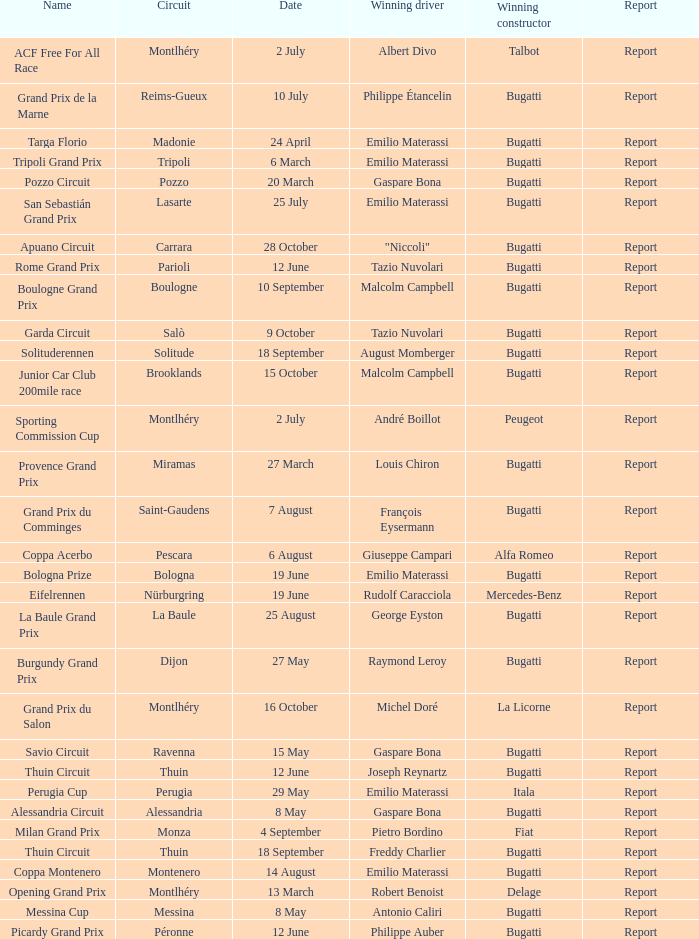Could you parse the entire table? {'header': ['Name', 'Circuit', 'Date', 'Winning driver', 'Winning constructor', 'Report'], 'rows': [['ACF Free For All Race', 'Montlhéry', '2 July', 'Albert Divo', 'Talbot', 'Report'], ['Grand Prix de la Marne', 'Reims-Gueux', '10 July', 'Philippe Étancelin', 'Bugatti', 'Report'], ['Targa Florio', 'Madonie', '24 April', 'Emilio Materassi', 'Bugatti', 'Report'], ['Tripoli Grand Prix', 'Tripoli', '6 March', 'Emilio Materassi', 'Bugatti', 'Report'], ['Pozzo Circuit', 'Pozzo', '20 March', 'Gaspare Bona', 'Bugatti', 'Report'], ['San Sebastián Grand Prix', 'Lasarte', '25 July', 'Emilio Materassi', 'Bugatti', 'Report'], ['Apuano Circuit', 'Carrara', '28 October', '"Niccoli"', 'Bugatti', 'Report'], ['Rome Grand Prix', 'Parioli', '12 June', 'Tazio Nuvolari', 'Bugatti', 'Report'], ['Boulogne Grand Prix', 'Boulogne', '10 September', 'Malcolm Campbell', 'Bugatti', 'Report'], ['Garda Circuit', 'Salò', '9 October', 'Tazio Nuvolari', 'Bugatti', 'Report'], ['Solituderennen', 'Solitude', '18 September', 'August Momberger', 'Bugatti', 'Report'], ['Junior Car Club 200mile race', 'Brooklands', '15 October', 'Malcolm Campbell', 'Bugatti', 'Report'], ['Sporting Commission Cup', 'Montlhéry', '2 July', 'André Boillot', 'Peugeot', 'Report'], ['Provence Grand Prix', 'Miramas', '27 March', 'Louis Chiron', 'Bugatti', 'Report'], ['Grand Prix du Comminges', 'Saint-Gaudens', '7 August', 'François Eysermann', 'Bugatti', 'Report'], ['Coppa Acerbo', 'Pescara', '6 August', 'Giuseppe Campari', 'Alfa Romeo', 'Report'], ['Bologna Prize', 'Bologna', '19 June', 'Emilio Materassi', 'Bugatti', 'Report'], ['Eifelrennen', 'Nürburgring', '19 June', 'Rudolf Caracciola', 'Mercedes-Benz', 'Report'], ['La Baule Grand Prix', 'La Baule', '25 August', 'George Eyston', 'Bugatti', 'Report'], ['Burgundy Grand Prix', 'Dijon', '27 May', 'Raymond Leroy', 'Bugatti', 'Report'], ['Grand Prix du Salon', 'Montlhéry', '16 October', 'Michel Doré', 'La Licorne', 'Report'], ['Savio Circuit', 'Ravenna', '15 May', 'Gaspare Bona', 'Bugatti', 'Report'], ['Thuin Circuit', 'Thuin', '12 June', 'Joseph Reynartz', 'Bugatti', 'Report'], ['Perugia Cup', 'Perugia', '29 May', 'Emilio Materassi', 'Itala', 'Report'], ['Alessandria Circuit', 'Alessandria', '8 May', 'Gaspare Bona', 'Bugatti', 'Report'], ['Milan Grand Prix', 'Monza', '4 September', 'Pietro Bordino', 'Fiat', 'Report'], ['Thuin Circuit', 'Thuin', '18 September', 'Freddy Charlier', 'Bugatti', 'Report'], ['Coppa Montenero', 'Montenero', '14 August', 'Emilio Materassi', 'Bugatti', 'Report'], ['Opening Grand Prix', 'Montlhéry', '13 March', 'Robert Benoist', 'Delage', 'Report'], ['Messina Cup', 'Messina', '8 May', 'Antonio Caliri', 'Bugatti', 'Report'], ['Picardy Grand Prix', 'Péronne', '12 June', 'Philippe Auber', 'Bugatti', 'Report']]} Which circuit did françois eysermann win ? Saint-Gaudens. 